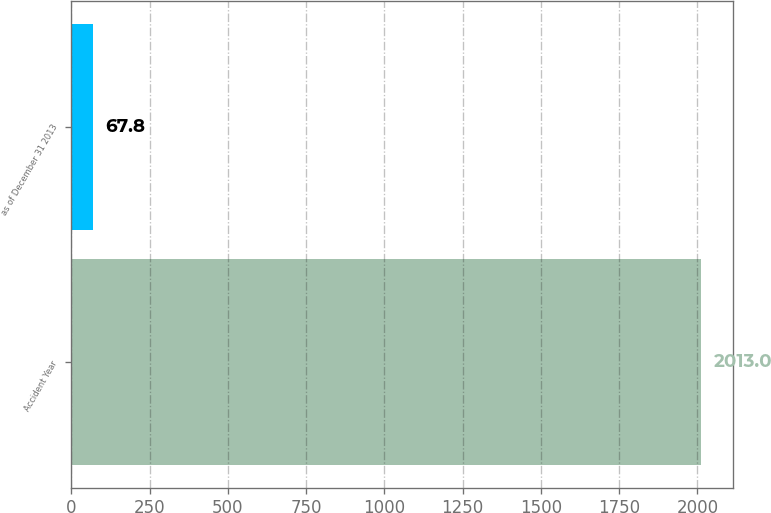<chart> <loc_0><loc_0><loc_500><loc_500><bar_chart><fcel>Accident Year<fcel>as of December 31 2013<nl><fcel>2013<fcel>67.8<nl></chart> 